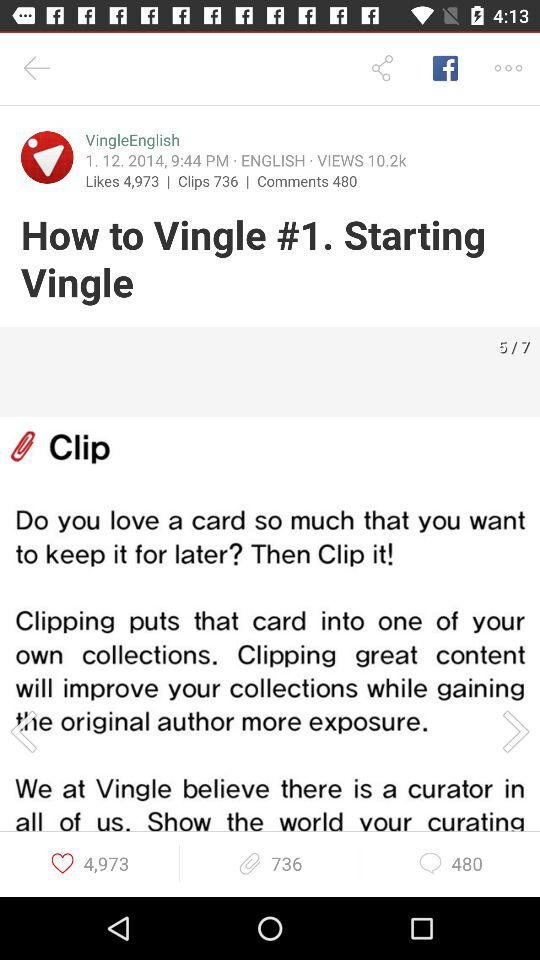How many more clips than comments does the video have?
Answer the question using a single word or phrase. 256 